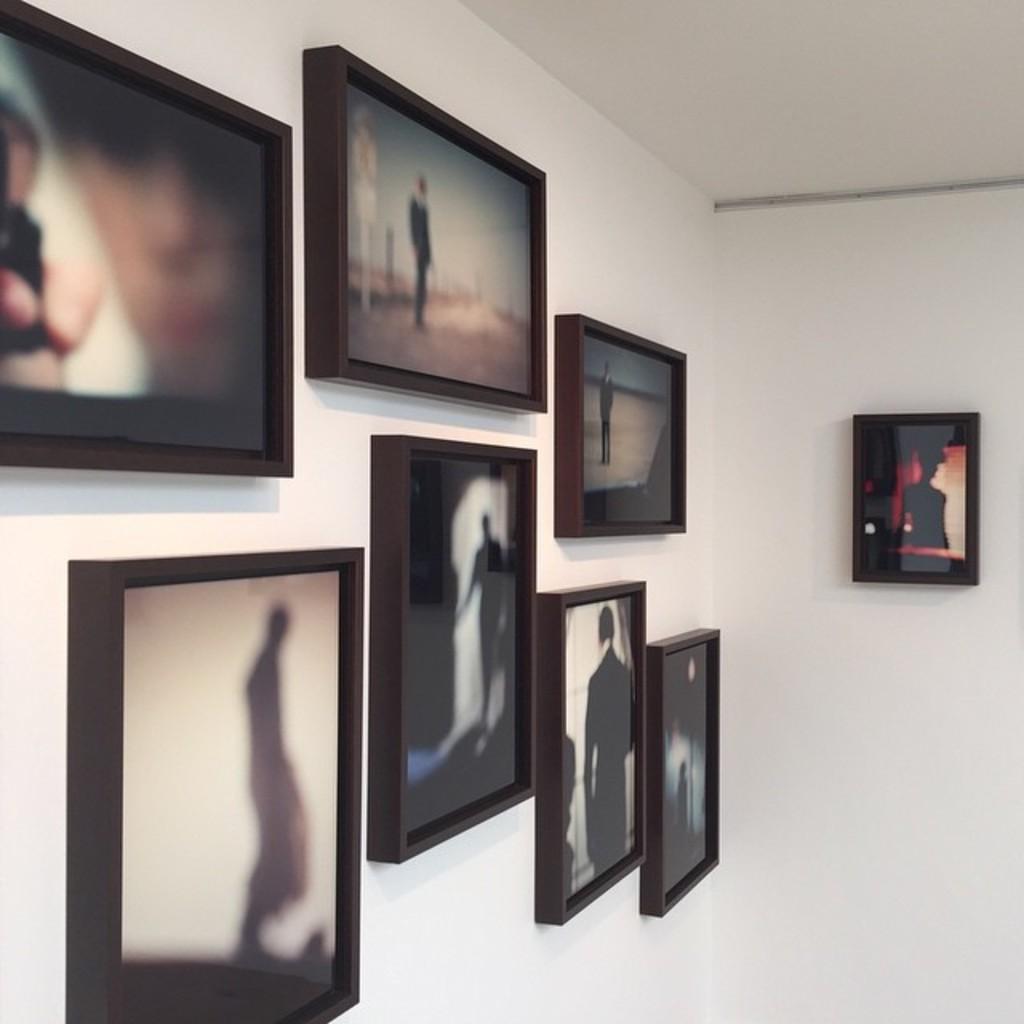In one or two sentences, can you explain what this image depicts? In this image I see the white wall on which there are photo frames and on the photo frames I see a person in every photo. 